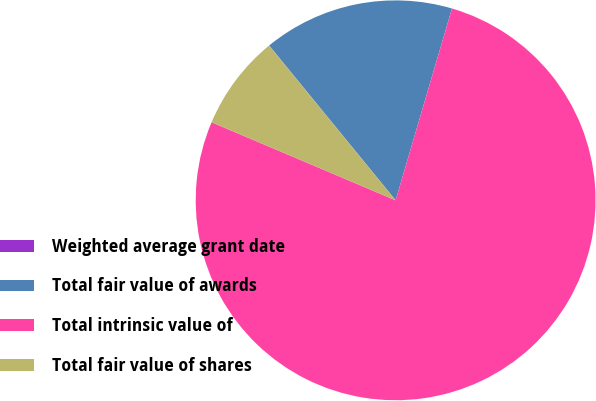Convert chart. <chart><loc_0><loc_0><loc_500><loc_500><pie_chart><fcel>Weighted average grant date<fcel>Total fair value of awards<fcel>Total intrinsic value of<fcel>Total fair value of shares<nl><fcel>0.02%<fcel>15.44%<fcel>76.83%<fcel>7.7%<nl></chart> 